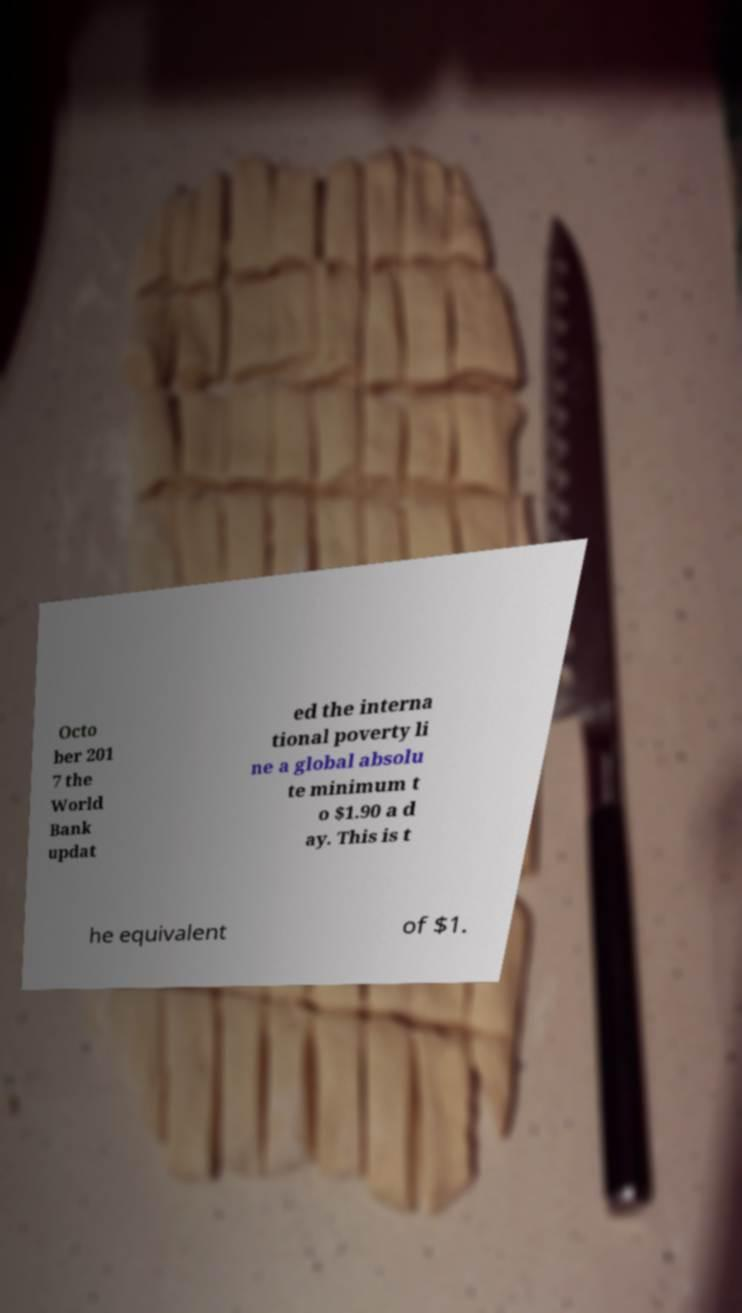Please read and relay the text visible in this image. What does it say? Octo ber 201 7 the World Bank updat ed the interna tional poverty li ne a global absolu te minimum t o $1.90 a d ay. This is t he equivalent of $1. 